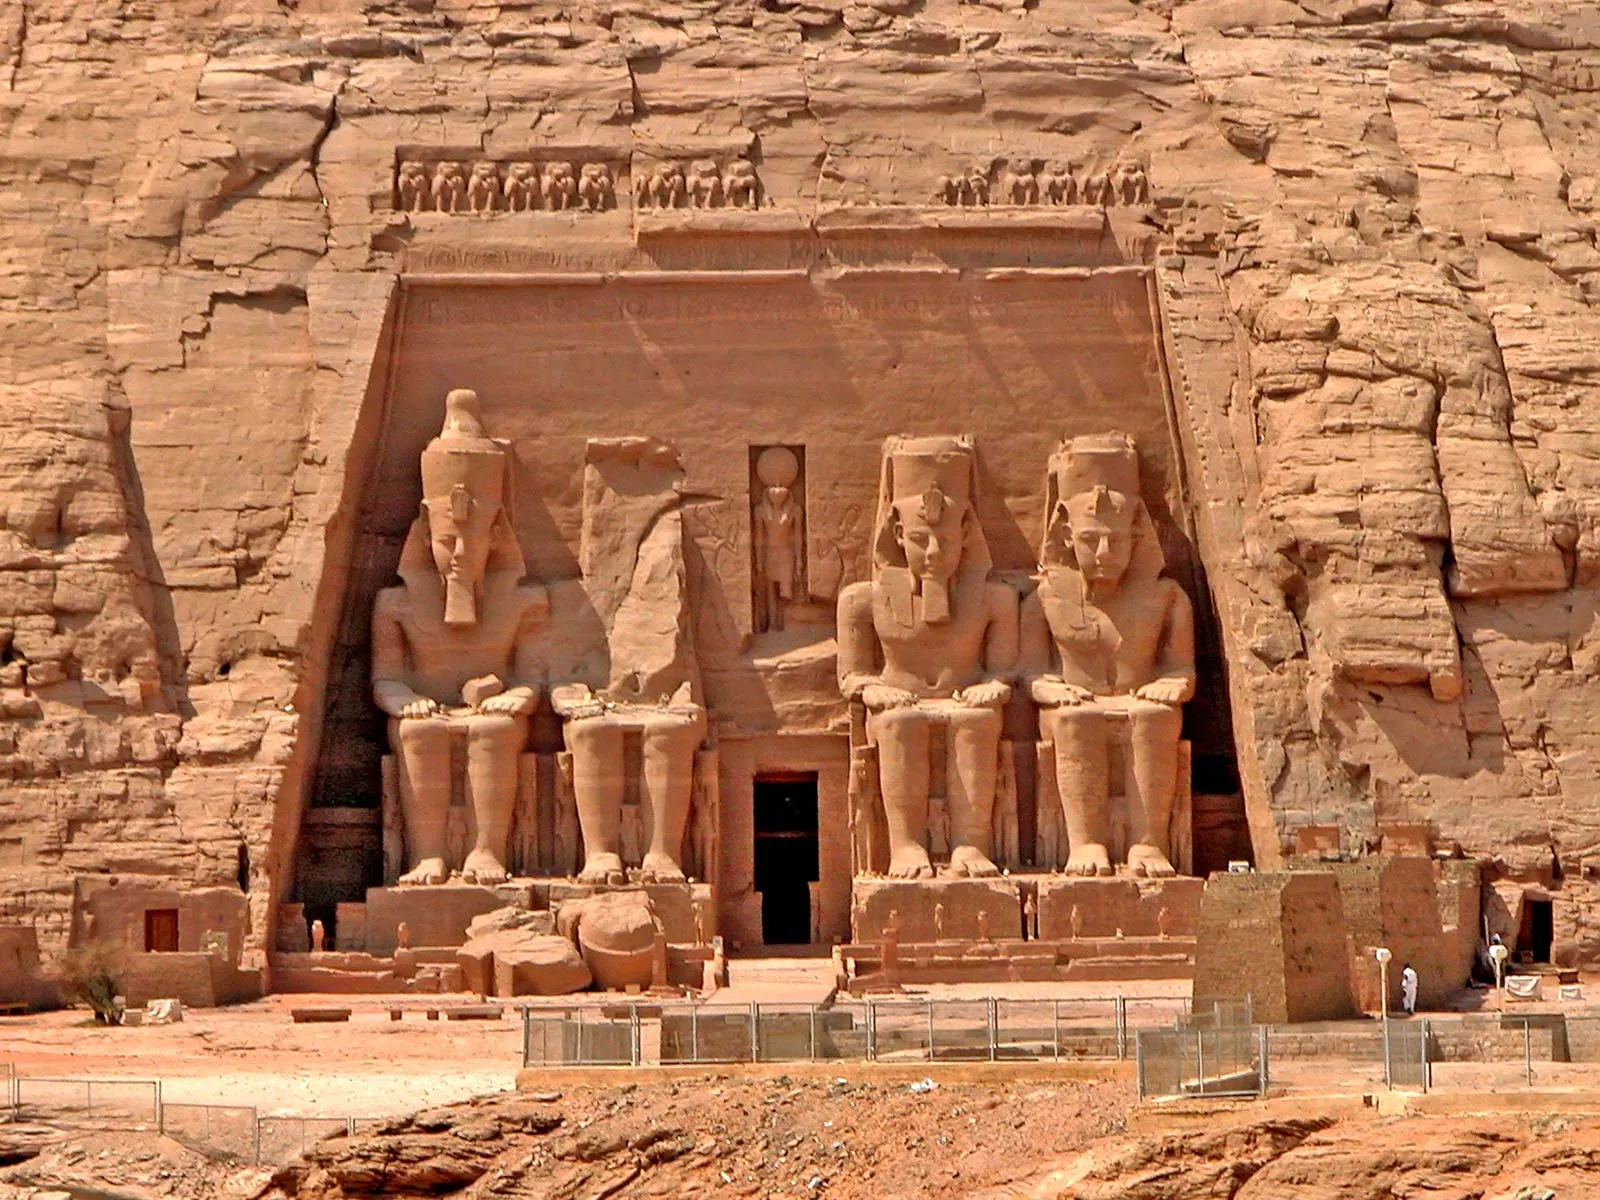Supposing a hidden chamber is discovered behind the temple, what artifacts might we find inside? Imagine a hidden chamber behind the Abu Simbel temple filled with ancient treasures. Inside, we might find intricately designed sarcophagi adorned with gold and precious stones, containing the mummies of high-ranking officials or family members of Ramesses II. There could be exquisite jewelry sets, including necklaces, bracelets, and rings crafted from gold, lapis lazuli, and carnelian. Hieroglyph-inscribed papyrus scrolls might reveal new historical records or religious texts. The chamber could also contain statues of deities, crafted from various materials like bronze, alabaster, and ebony. Pottery and alabaster jars filled with essential oils, perfumes, and offerings prepared for the afterlife might be present, alongside beautifully painted murals depicting scenes of daily life, warfare, and religious rituals. These artifacts would provide a deeper understanding of the opulence, beliefs, and customs of ancient Egypt. 